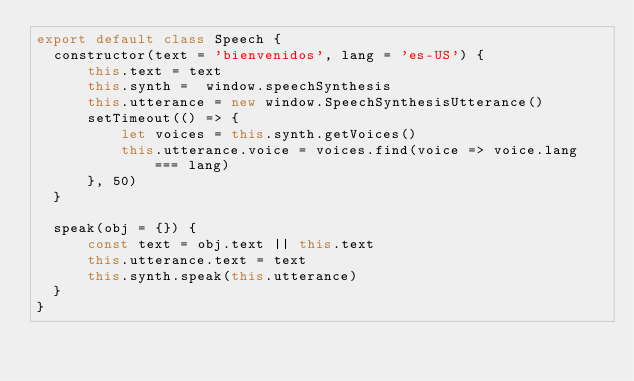Convert code to text. <code><loc_0><loc_0><loc_500><loc_500><_JavaScript_>export default class Speech {
  constructor(text = 'bienvenidos', lang = 'es-US') {
      this.text = text
      this.synth =  window.speechSynthesis
      this.utterance = new window.SpeechSynthesisUtterance()
      setTimeout(() => {
          let voices = this.synth.getVoices()
          this.utterance.voice = voices.find(voice => voice.lang === lang)
      }, 50)
  }

  speak(obj = {}) {
      const text = obj.text || this.text
      this.utterance.text = text
      this.synth.speak(this.utterance)
  }
}
</code> 